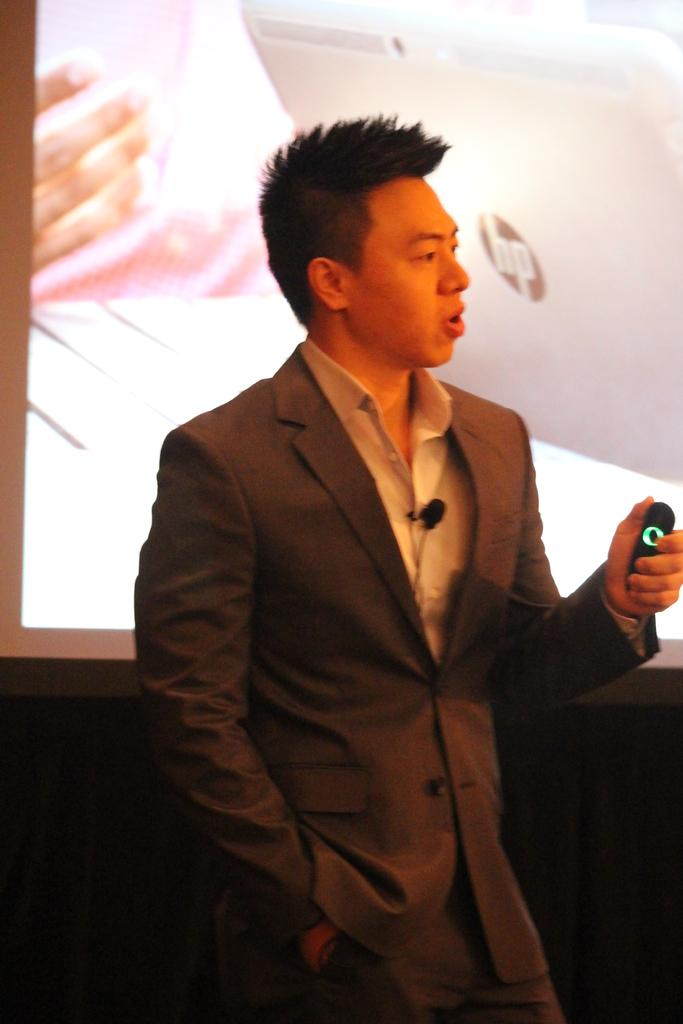Who is present in the image? There is a man in the image. What is the man holding in the image? The man is holding a remote. What can be seen in the background of the image? There is a screen in the background of the image. What is displayed on the screen? The screen displays a laptop. What color is the sock the man is wearing in the image? There is no sock visible in the image, as the man is not wearing any footwear. 